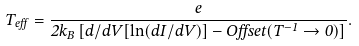<formula> <loc_0><loc_0><loc_500><loc_500>T _ { e f f } = \frac { e } { 2 k _ { B } \left [ d / d V [ \ln ( d I / d V ) ] - O f f s e t ( T ^ { - 1 } \rightarrow 0 ) \right ] } .</formula> 